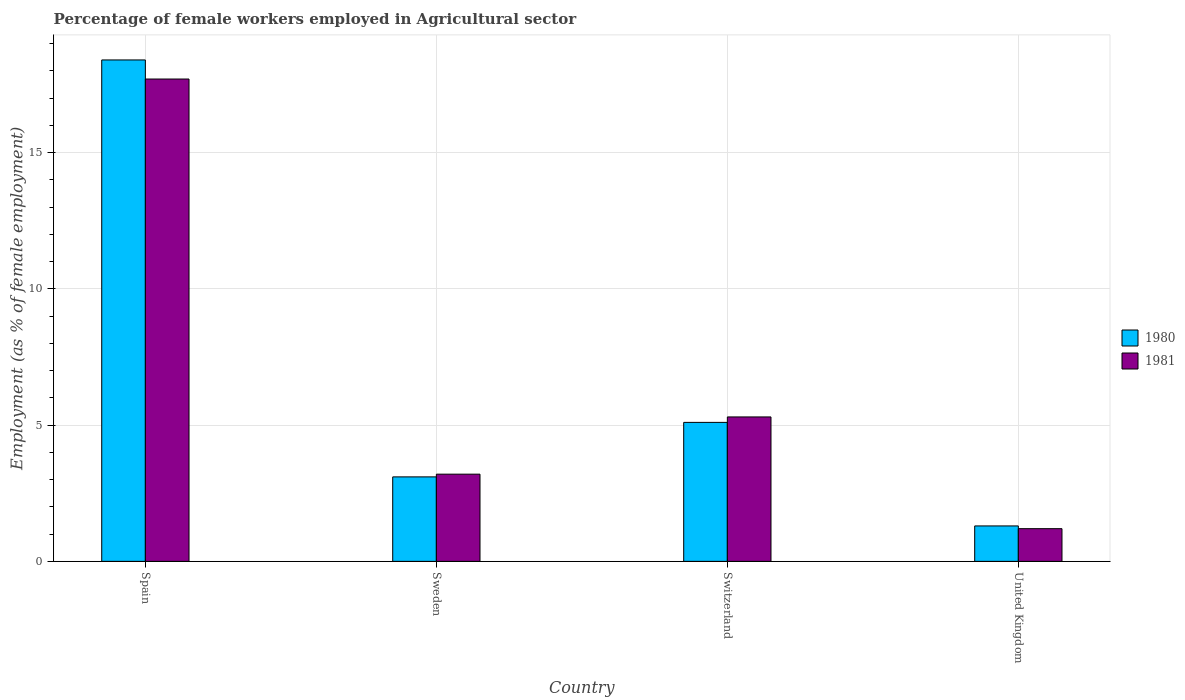Are the number of bars per tick equal to the number of legend labels?
Your answer should be compact. Yes. How many bars are there on the 1st tick from the left?
Your answer should be very brief. 2. How many bars are there on the 4th tick from the right?
Offer a very short reply. 2. What is the label of the 1st group of bars from the left?
Offer a very short reply. Spain. In how many cases, is the number of bars for a given country not equal to the number of legend labels?
Make the answer very short. 0. What is the percentage of females employed in Agricultural sector in 1981 in Sweden?
Give a very brief answer. 3.2. Across all countries, what is the maximum percentage of females employed in Agricultural sector in 1981?
Give a very brief answer. 17.7. Across all countries, what is the minimum percentage of females employed in Agricultural sector in 1980?
Provide a succinct answer. 1.3. In which country was the percentage of females employed in Agricultural sector in 1981 minimum?
Provide a succinct answer. United Kingdom. What is the total percentage of females employed in Agricultural sector in 1980 in the graph?
Make the answer very short. 27.9. What is the difference between the percentage of females employed in Agricultural sector in 1981 in Sweden and that in United Kingdom?
Make the answer very short. 2. What is the difference between the percentage of females employed in Agricultural sector in 1981 in Sweden and the percentage of females employed in Agricultural sector in 1980 in United Kingdom?
Give a very brief answer. 1.9. What is the average percentage of females employed in Agricultural sector in 1981 per country?
Ensure brevity in your answer.  6.85. What is the difference between the percentage of females employed in Agricultural sector of/in 1981 and percentage of females employed in Agricultural sector of/in 1980 in Spain?
Offer a terse response. -0.7. In how many countries, is the percentage of females employed in Agricultural sector in 1980 greater than 8 %?
Your response must be concise. 1. What is the ratio of the percentage of females employed in Agricultural sector in 1981 in Sweden to that in Switzerland?
Your answer should be compact. 0.6. Is the percentage of females employed in Agricultural sector in 1980 in Spain less than that in United Kingdom?
Make the answer very short. No. Is the difference between the percentage of females employed in Agricultural sector in 1981 in Switzerland and United Kingdom greater than the difference between the percentage of females employed in Agricultural sector in 1980 in Switzerland and United Kingdom?
Provide a succinct answer. Yes. What is the difference between the highest and the second highest percentage of females employed in Agricultural sector in 1981?
Provide a short and direct response. 14.5. What is the difference between the highest and the lowest percentage of females employed in Agricultural sector in 1981?
Your answer should be very brief. 16.5. In how many countries, is the percentage of females employed in Agricultural sector in 1981 greater than the average percentage of females employed in Agricultural sector in 1981 taken over all countries?
Give a very brief answer. 1. Is the sum of the percentage of females employed in Agricultural sector in 1980 in Spain and United Kingdom greater than the maximum percentage of females employed in Agricultural sector in 1981 across all countries?
Your response must be concise. Yes. How many bars are there?
Your response must be concise. 8. How many countries are there in the graph?
Keep it short and to the point. 4. Does the graph contain any zero values?
Provide a short and direct response. No. How many legend labels are there?
Make the answer very short. 2. How are the legend labels stacked?
Your response must be concise. Vertical. What is the title of the graph?
Ensure brevity in your answer.  Percentage of female workers employed in Agricultural sector. What is the label or title of the X-axis?
Keep it short and to the point. Country. What is the label or title of the Y-axis?
Provide a succinct answer. Employment (as % of female employment). What is the Employment (as % of female employment) of 1980 in Spain?
Make the answer very short. 18.4. What is the Employment (as % of female employment) in 1981 in Spain?
Provide a succinct answer. 17.7. What is the Employment (as % of female employment) of 1980 in Sweden?
Give a very brief answer. 3.1. What is the Employment (as % of female employment) of 1981 in Sweden?
Your answer should be compact. 3.2. What is the Employment (as % of female employment) in 1980 in Switzerland?
Provide a succinct answer. 5.1. What is the Employment (as % of female employment) in 1981 in Switzerland?
Provide a short and direct response. 5.3. What is the Employment (as % of female employment) of 1980 in United Kingdom?
Your answer should be compact. 1.3. What is the Employment (as % of female employment) in 1981 in United Kingdom?
Provide a short and direct response. 1.2. Across all countries, what is the maximum Employment (as % of female employment) of 1980?
Provide a succinct answer. 18.4. Across all countries, what is the maximum Employment (as % of female employment) in 1981?
Your response must be concise. 17.7. Across all countries, what is the minimum Employment (as % of female employment) in 1980?
Offer a very short reply. 1.3. Across all countries, what is the minimum Employment (as % of female employment) in 1981?
Your answer should be very brief. 1.2. What is the total Employment (as % of female employment) of 1980 in the graph?
Keep it short and to the point. 27.9. What is the total Employment (as % of female employment) of 1981 in the graph?
Give a very brief answer. 27.4. What is the difference between the Employment (as % of female employment) of 1980 in Spain and that in Sweden?
Offer a very short reply. 15.3. What is the difference between the Employment (as % of female employment) of 1980 in Spain and that in Switzerland?
Provide a short and direct response. 13.3. What is the difference between the Employment (as % of female employment) in 1981 in Spain and that in Switzerland?
Give a very brief answer. 12.4. What is the difference between the Employment (as % of female employment) in 1980 in Spain and that in United Kingdom?
Give a very brief answer. 17.1. What is the difference between the Employment (as % of female employment) of 1981 in Spain and that in United Kingdom?
Ensure brevity in your answer.  16.5. What is the difference between the Employment (as % of female employment) of 1980 in Sweden and that in Switzerland?
Provide a succinct answer. -2. What is the difference between the Employment (as % of female employment) in 1981 in Sweden and that in United Kingdom?
Provide a short and direct response. 2. What is the difference between the Employment (as % of female employment) in 1980 in Sweden and the Employment (as % of female employment) in 1981 in Switzerland?
Your answer should be compact. -2.2. What is the difference between the Employment (as % of female employment) of 1980 in Switzerland and the Employment (as % of female employment) of 1981 in United Kingdom?
Your answer should be compact. 3.9. What is the average Employment (as % of female employment) in 1980 per country?
Give a very brief answer. 6.97. What is the average Employment (as % of female employment) in 1981 per country?
Ensure brevity in your answer.  6.85. What is the difference between the Employment (as % of female employment) in 1980 and Employment (as % of female employment) in 1981 in Spain?
Your answer should be very brief. 0.7. What is the difference between the Employment (as % of female employment) of 1980 and Employment (as % of female employment) of 1981 in Switzerland?
Your answer should be very brief. -0.2. What is the difference between the Employment (as % of female employment) of 1980 and Employment (as % of female employment) of 1981 in United Kingdom?
Provide a succinct answer. 0.1. What is the ratio of the Employment (as % of female employment) in 1980 in Spain to that in Sweden?
Offer a very short reply. 5.94. What is the ratio of the Employment (as % of female employment) of 1981 in Spain to that in Sweden?
Offer a very short reply. 5.53. What is the ratio of the Employment (as % of female employment) in 1980 in Spain to that in Switzerland?
Provide a succinct answer. 3.61. What is the ratio of the Employment (as % of female employment) in 1981 in Spain to that in Switzerland?
Offer a terse response. 3.34. What is the ratio of the Employment (as % of female employment) of 1980 in Spain to that in United Kingdom?
Ensure brevity in your answer.  14.15. What is the ratio of the Employment (as % of female employment) in 1981 in Spain to that in United Kingdom?
Give a very brief answer. 14.75. What is the ratio of the Employment (as % of female employment) of 1980 in Sweden to that in Switzerland?
Provide a short and direct response. 0.61. What is the ratio of the Employment (as % of female employment) in 1981 in Sweden to that in Switzerland?
Your answer should be compact. 0.6. What is the ratio of the Employment (as % of female employment) in 1980 in Sweden to that in United Kingdom?
Provide a succinct answer. 2.38. What is the ratio of the Employment (as % of female employment) in 1981 in Sweden to that in United Kingdom?
Provide a short and direct response. 2.67. What is the ratio of the Employment (as % of female employment) in 1980 in Switzerland to that in United Kingdom?
Ensure brevity in your answer.  3.92. What is the ratio of the Employment (as % of female employment) of 1981 in Switzerland to that in United Kingdom?
Make the answer very short. 4.42. What is the difference between the highest and the second highest Employment (as % of female employment) in 1980?
Your answer should be compact. 13.3. What is the difference between the highest and the lowest Employment (as % of female employment) of 1980?
Ensure brevity in your answer.  17.1. What is the difference between the highest and the lowest Employment (as % of female employment) in 1981?
Your answer should be compact. 16.5. 